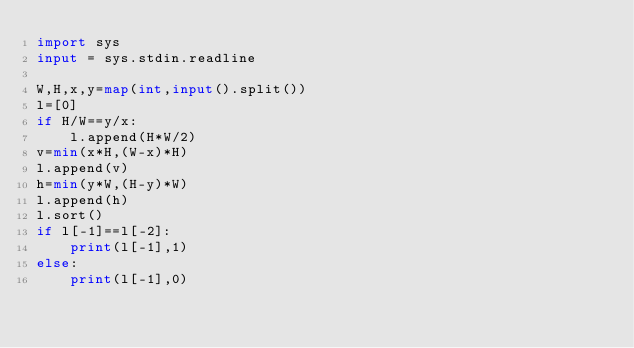<code> <loc_0><loc_0><loc_500><loc_500><_Python_>import sys
input = sys.stdin.readline

W,H,x,y=map(int,input().split())
l=[0]
if H/W==y/x:
    l.append(H*W/2)
v=min(x*H,(W-x)*H)
l.append(v)
h=min(y*W,(H-y)*W)
l.append(h)
l.sort()
if l[-1]==l[-2]:
    print(l[-1],1)
else:
    print(l[-1],0)</code> 